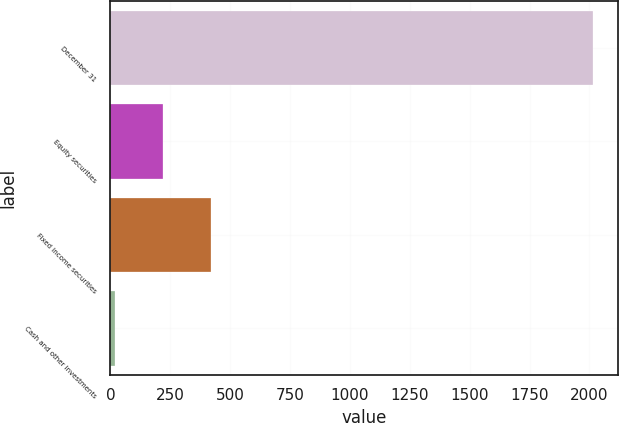Convert chart to OTSL. <chart><loc_0><loc_0><loc_500><loc_500><bar_chart><fcel>December 31<fcel>Equity securities<fcel>Fixed income securities<fcel>Cash and other investments<nl><fcel>2017<fcel>219.7<fcel>419.4<fcel>20<nl></chart> 